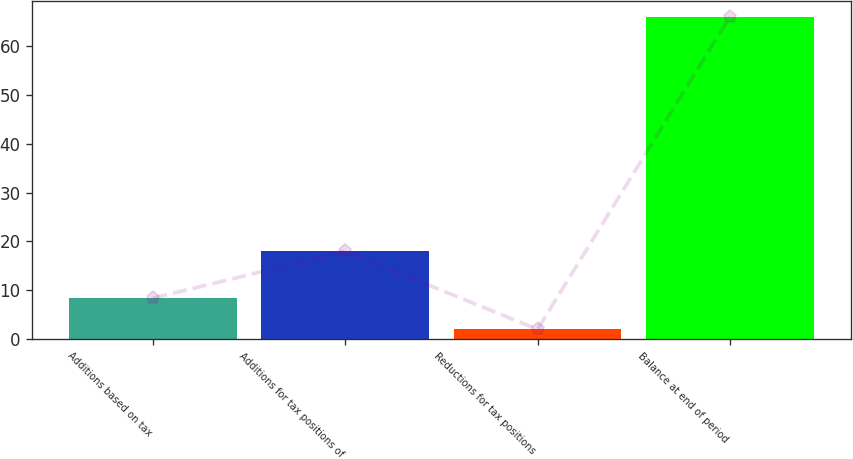<chart> <loc_0><loc_0><loc_500><loc_500><bar_chart><fcel>Additions based on tax<fcel>Additions for tax positions of<fcel>Reductions for tax positions<fcel>Balance at end of period<nl><fcel>8.4<fcel>18<fcel>2<fcel>66<nl></chart> 